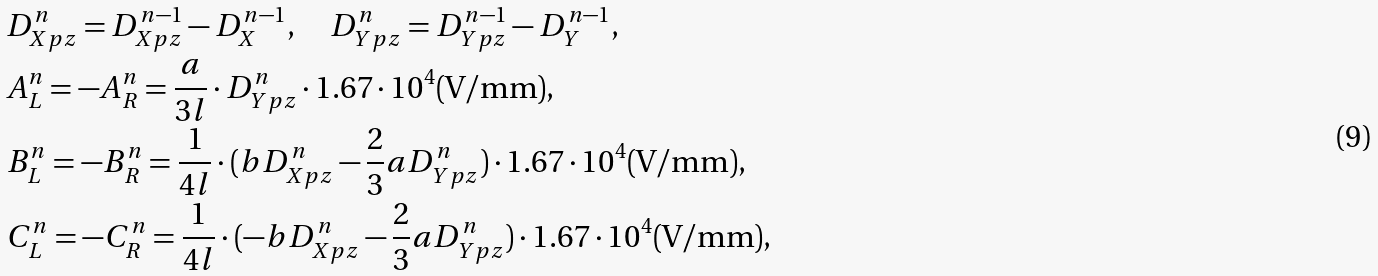Convert formula to latex. <formula><loc_0><loc_0><loc_500><loc_500>& D ^ { n } _ { X p z } = D ^ { n - 1 } _ { X p z } - D ^ { n - 1 } _ { X } , \quad D ^ { n } _ { Y p z } = D ^ { n - 1 } _ { Y p z } - D ^ { n - 1 } _ { Y } , \\ & A ^ { n } _ { L } = - A ^ { n } _ { R } = \frac { a } { 3 l } \cdot D ^ { n } _ { Y p z } \cdot 1 . 6 7 \cdot 1 0 ^ { 4 } ( \text {V/mm} ) , \\ & B ^ { n } _ { L } = - B ^ { n } _ { R } = \frac { 1 } { 4 l } \cdot ( b D ^ { n } _ { X p z } - \frac { 2 } { 3 } a D ^ { n } _ { Y p z } ) \cdot 1 . 6 7 \cdot 1 0 ^ { 4 } ( \text {V/mm} ) , \\ & C ^ { n } _ { L } = - C ^ { n } _ { R } = \frac { 1 } { 4 l } \cdot ( - b D ^ { n } _ { X p z } - \frac { 2 } { 3 } a D ^ { n } _ { Y p z } ) \cdot 1 . 6 7 \cdot 1 0 ^ { 4 } ( \text {V/mm} ) ,</formula> 